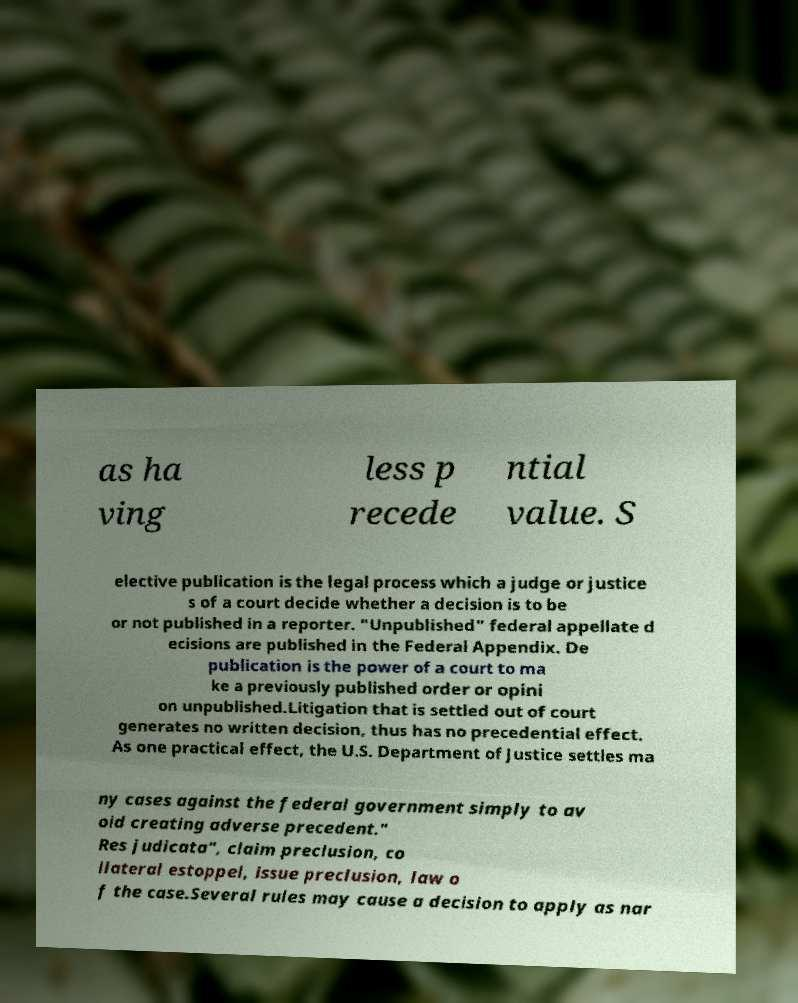For documentation purposes, I need the text within this image transcribed. Could you provide that? as ha ving less p recede ntial value. S elective publication is the legal process which a judge or justice s of a court decide whether a decision is to be or not published in a reporter. "Unpublished" federal appellate d ecisions are published in the Federal Appendix. De publication is the power of a court to ma ke a previously published order or opini on unpublished.Litigation that is settled out of court generates no written decision, thus has no precedential effect. As one practical effect, the U.S. Department of Justice settles ma ny cases against the federal government simply to av oid creating adverse precedent." Res judicata", claim preclusion, co llateral estoppel, issue preclusion, law o f the case.Several rules may cause a decision to apply as nar 